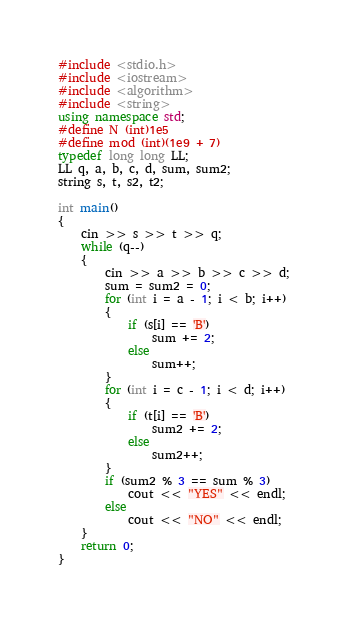<code> <loc_0><loc_0><loc_500><loc_500><_C++_>#include <stdio.h>
#include <iostream>
#include <algorithm>
#include <string>
using namespace std;
#define N (int)1e5
#define mod (int)(1e9 + 7)
typedef long long LL;
LL q, a, b, c, d, sum, sum2;
string s, t, s2, t2;

int main()
{
	cin >> s >> t >> q;
	while (q--)
	{
		cin >> a >> b >> c >> d;
		sum = sum2 = 0;
		for (int i = a - 1; i < b; i++)
		{
			if (s[i] == 'B')
				sum += 2;
			else
				sum++;
		}
		for (int i = c - 1; i < d; i++)
		{
			if (t[i] == 'B')
				sum2 += 2;
			else
				sum2++;
		}
		if (sum2 % 3 == sum % 3)
			cout << "YES" << endl;
		else
			cout << "NO" << endl;
	}
	return 0;
}</code> 